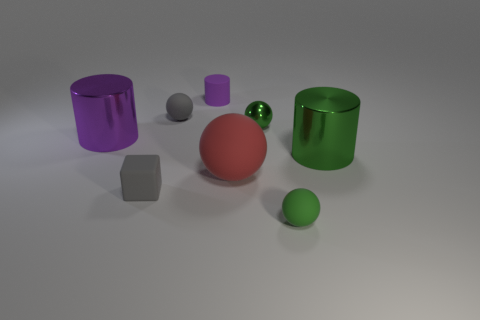Add 2 large purple metal cylinders. How many objects exist? 10 Subtract all cylinders. How many objects are left? 5 Add 2 big gray shiny cubes. How many big gray shiny cubes exist? 2 Subtract 0 purple spheres. How many objects are left? 8 Subtract all green rubber things. Subtract all big blue shiny balls. How many objects are left? 7 Add 1 matte cylinders. How many matte cylinders are left? 2 